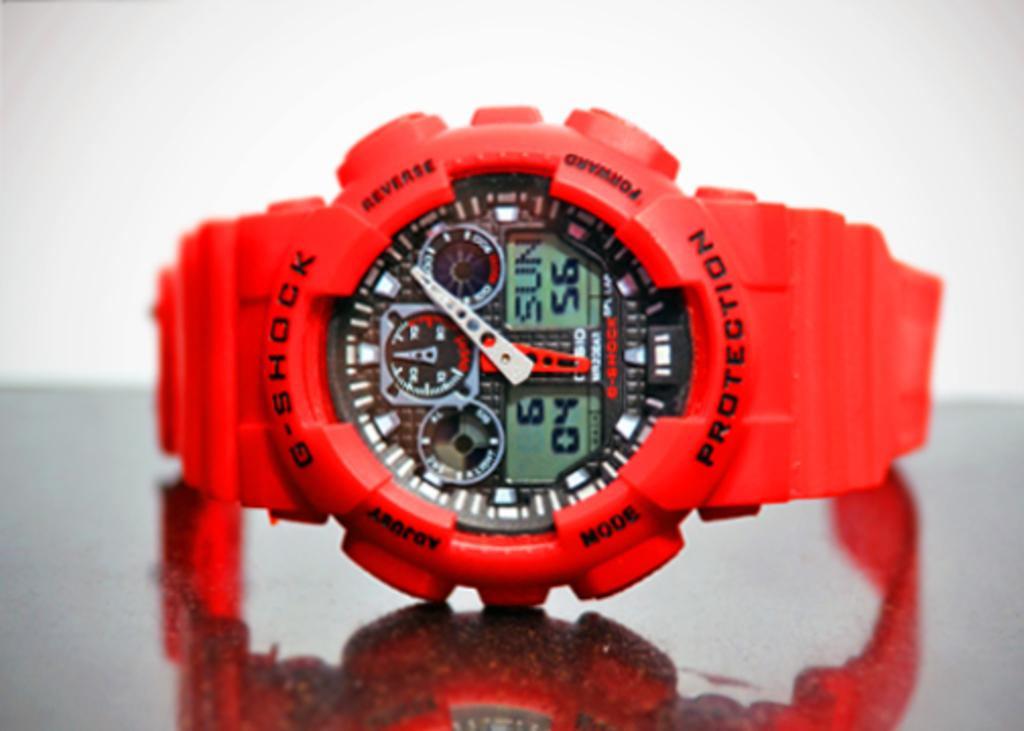<image>
Share a concise interpretation of the image provided. G shock protection red watch that includes a timer, day, and stop watch 